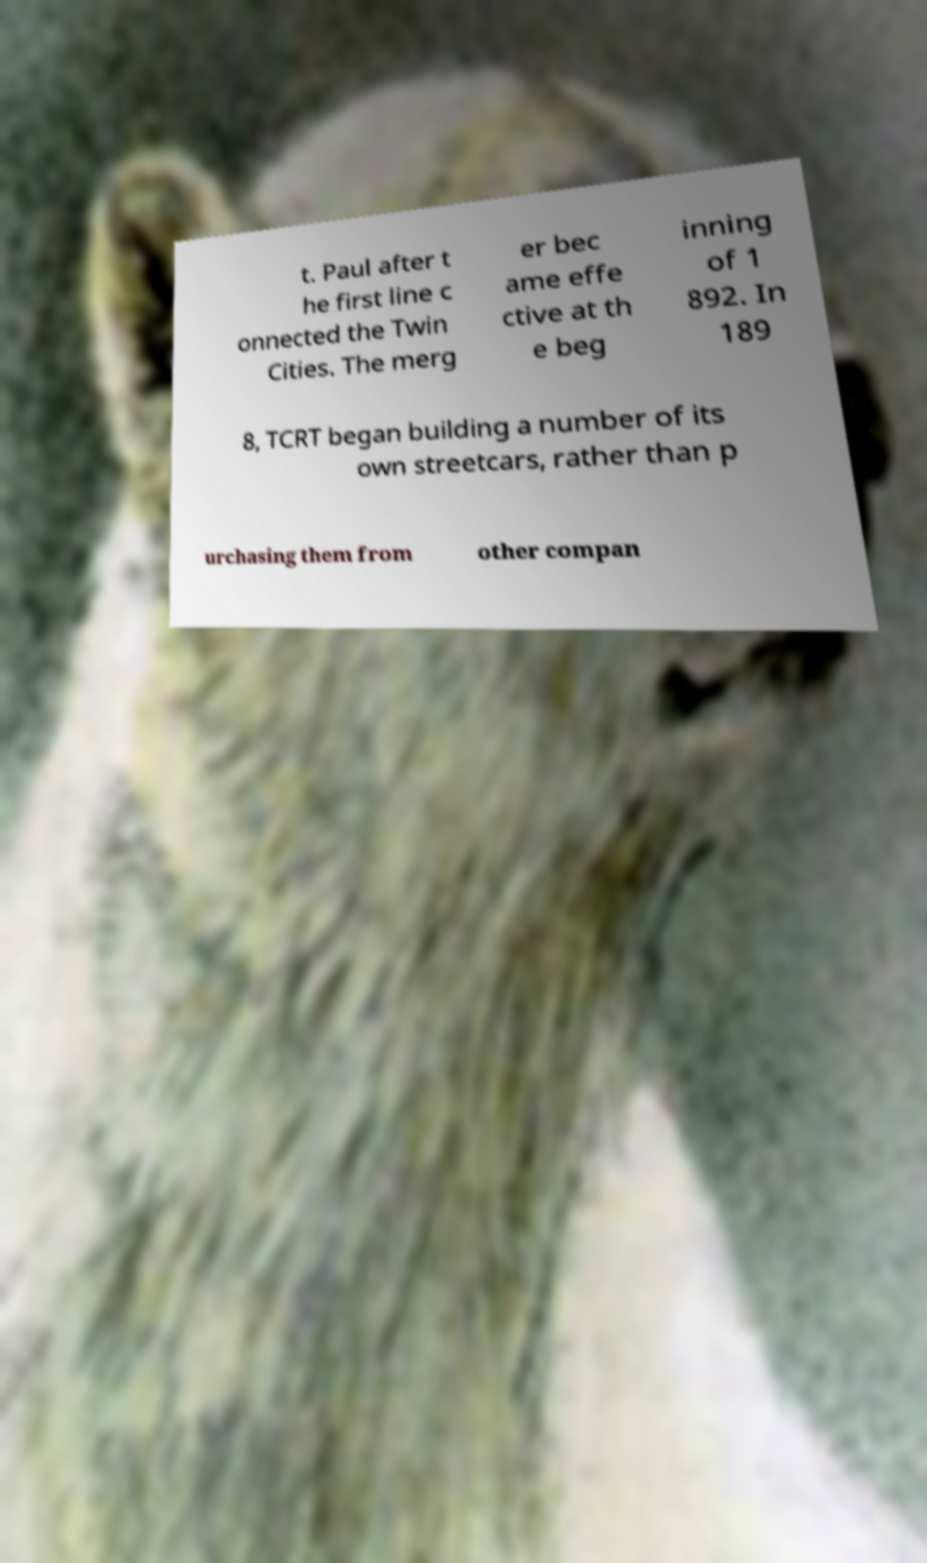For documentation purposes, I need the text within this image transcribed. Could you provide that? t. Paul after t he first line c onnected the Twin Cities. The merg er bec ame effe ctive at th e beg inning of 1 892. In 189 8, TCRT began building a number of its own streetcars, rather than p urchasing them from other compan 